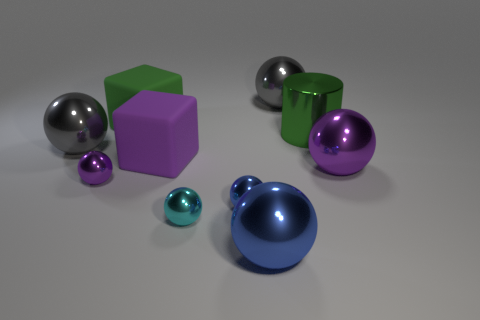What size is the gray metallic sphere that is in front of the ball that is behind the large gray metallic thing on the left side of the large blue thing?
Give a very brief answer. Large. There is a large thing that is both in front of the big purple rubber block and behind the cyan metal ball; what shape is it?
Offer a terse response. Sphere. Are there the same number of big blue shiny objects that are behind the metal cylinder and cylinders in front of the purple cube?
Your answer should be very brief. Yes. Are there any gray balls made of the same material as the tiny purple ball?
Your response must be concise. Yes. Is the material of the big ball behind the cylinder the same as the purple cube?
Provide a succinct answer. No. How big is the purple object that is both behind the small purple object and to the left of the small cyan thing?
Provide a short and direct response. Large. What color is the big shiny cylinder?
Keep it short and to the point. Green. What number of small cyan rubber cubes are there?
Offer a terse response. 0. What number of rubber things are the same color as the metallic cylinder?
Provide a succinct answer. 1. Is the shape of the big matte object that is to the left of the purple cube the same as the big purple object left of the small cyan object?
Provide a short and direct response. Yes. 